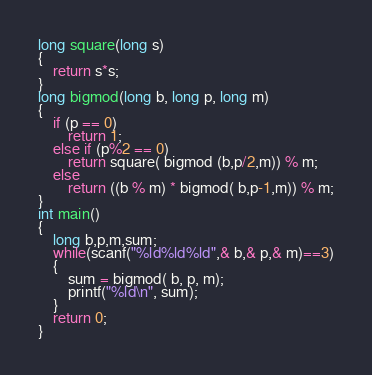<code> <loc_0><loc_0><loc_500><loc_500><_C++_>long square(long s)
{
    return s*s;
}
long bigmod(long b, long p, long m)
{
    if (p == 0)
        return 1;
    else if (p%2 == 0)
        return square( bigmod (b,p/2,m)) % m;
    else
        return ((b % m) * bigmod( b,p-1,m)) % m;
}
int main()
{
    long b,p,m,sum;
    while(scanf("%ld%ld%ld",& b,& p,& m)==3)
    {
        sum = bigmod( b, p, m);
        printf("%ld\n", sum);
    }
    return 0;
}
</code> 